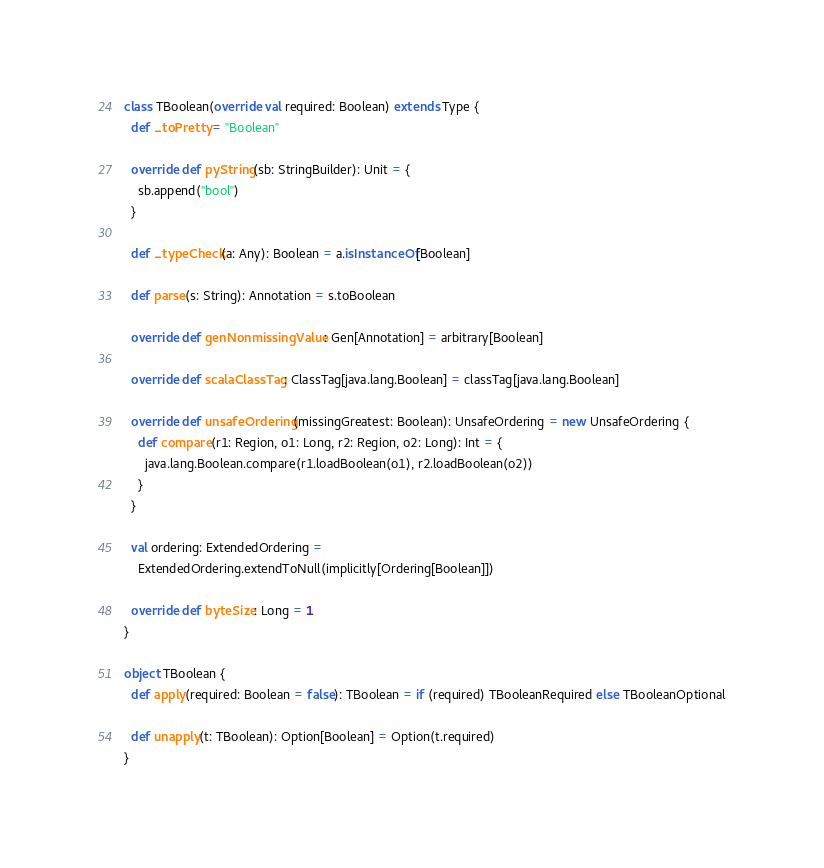Convert code to text. <code><loc_0><loc_0><loc_500><loc_500><_Scala_>class TBoolean(override val required: Boolean) extends Type {
  def _toPretty = "Boolean"

  override def pyString(sb: StringBuilder): Unit = {
    sb.append("bool")
  }

  def _typeCheck(a: Any): Boolean = a.isInstanceOf[Boolean]

  def parse(s: String): Annotation = s.toBoolean

  override def genNonmissingValue: Gen[Annotation] = arbitrary[Boolean]

  override def scalaClassTag: ClassTag[java.lang.Boolean] = classTag[java.lang.Boolean]

  override def unsafeOrdering(missingGreatest: Boolean): UnsafeOrdering = new UnsafeOrdering {
    def compare(r1: Region, o1: Long, r2: Region, o2: Long): Int = {
      java.lang.Boolean.compare(r1.loadBoolean(o1), r2.loadBoolean(o2))
    }
  }

  val ordering: ExtendedOrdering =
    ExtendedOrdering.extendToNull(implicitly[Ordering[Boolean]])

  override def byteSize: Long = 1
}

object TBoolean {
  def apply(required: Boolean = false): TBoolean = if (required) TBooleanRequired else TBooleanOptional

  def unapply(t: TBoolean): Option[Boolean] = Option(t.required)
}
</code> 